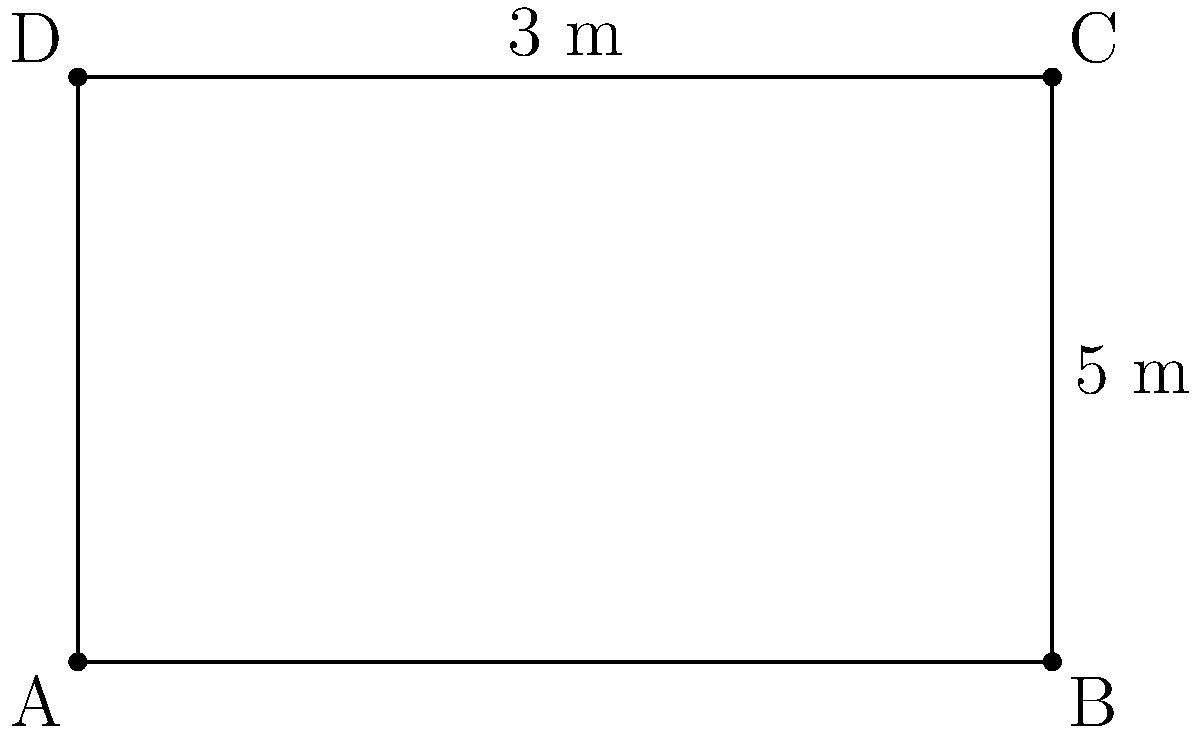A sociologist is planning a public awareness campaign about the dangers of pseudoscience in society. They want to use a rectangular billboard to display their message. The billboard measures 5 meters in width and 3 meters in height. What is the total surface area of the billboard that can be used for the campaign message? To calculate the surface area of the rectangular billboard, we need to use the formula for the area of a rectangle:

Area = length × width

Given:
- Width of the billboard = 5 meters
- Height of the billboard = 3 meters

Step 1: Apply the formula for the area of a rectangle.
Area = 5 m × 3 m

Step 2: Multiply the values.
Area = 15 m²

Therefore, the total surface area of the billboard that can be used for the campaign message is 15 square meters.
Answer: 15 m² 